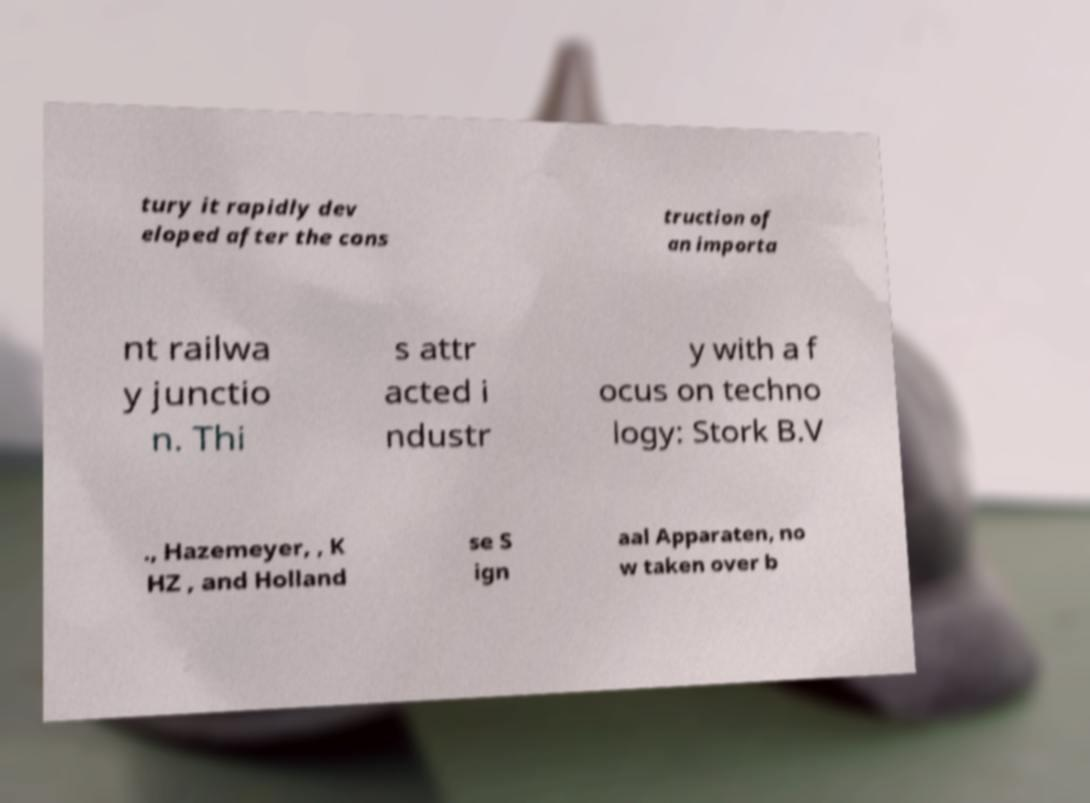For documentation purposes, I need the text within this image transcribed. Could you provide that? tury it rapidly dev eloped after the cons truction of an importa nt railwa y junctio n. Thi s attr acted i ndustr y with a f ocus on techno logy: Stork B.V ., Hazemeyer, , K HZ , and Holland se S ign aal Apparaten, no w taken over b 